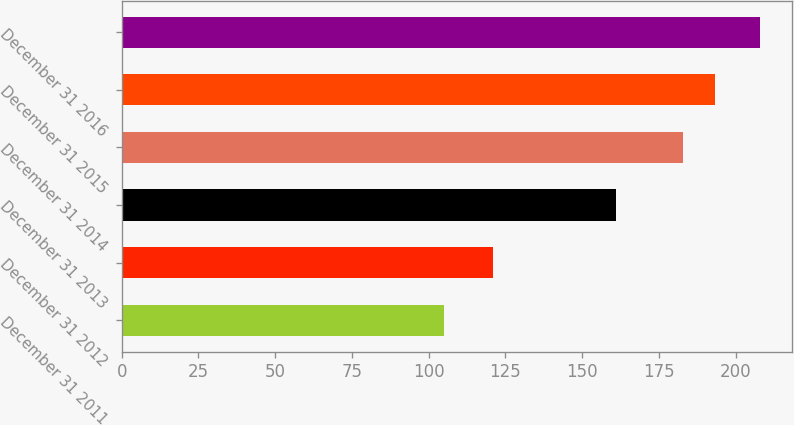Convert chart to OTSL. <chart><loc_0><loc_0><loc_500><loc_500><bar_chart><fcel>December 31 2011<fcel>December 31 2012<fcel>December 31 2013<fcel>December 31 2014<fcel>December 31 2015<fcel>December 31 2016<nl><fcel>105<fcel>121<fcel>161<fcel>183<fcel>193.3<fcel>208<nl></chart> 